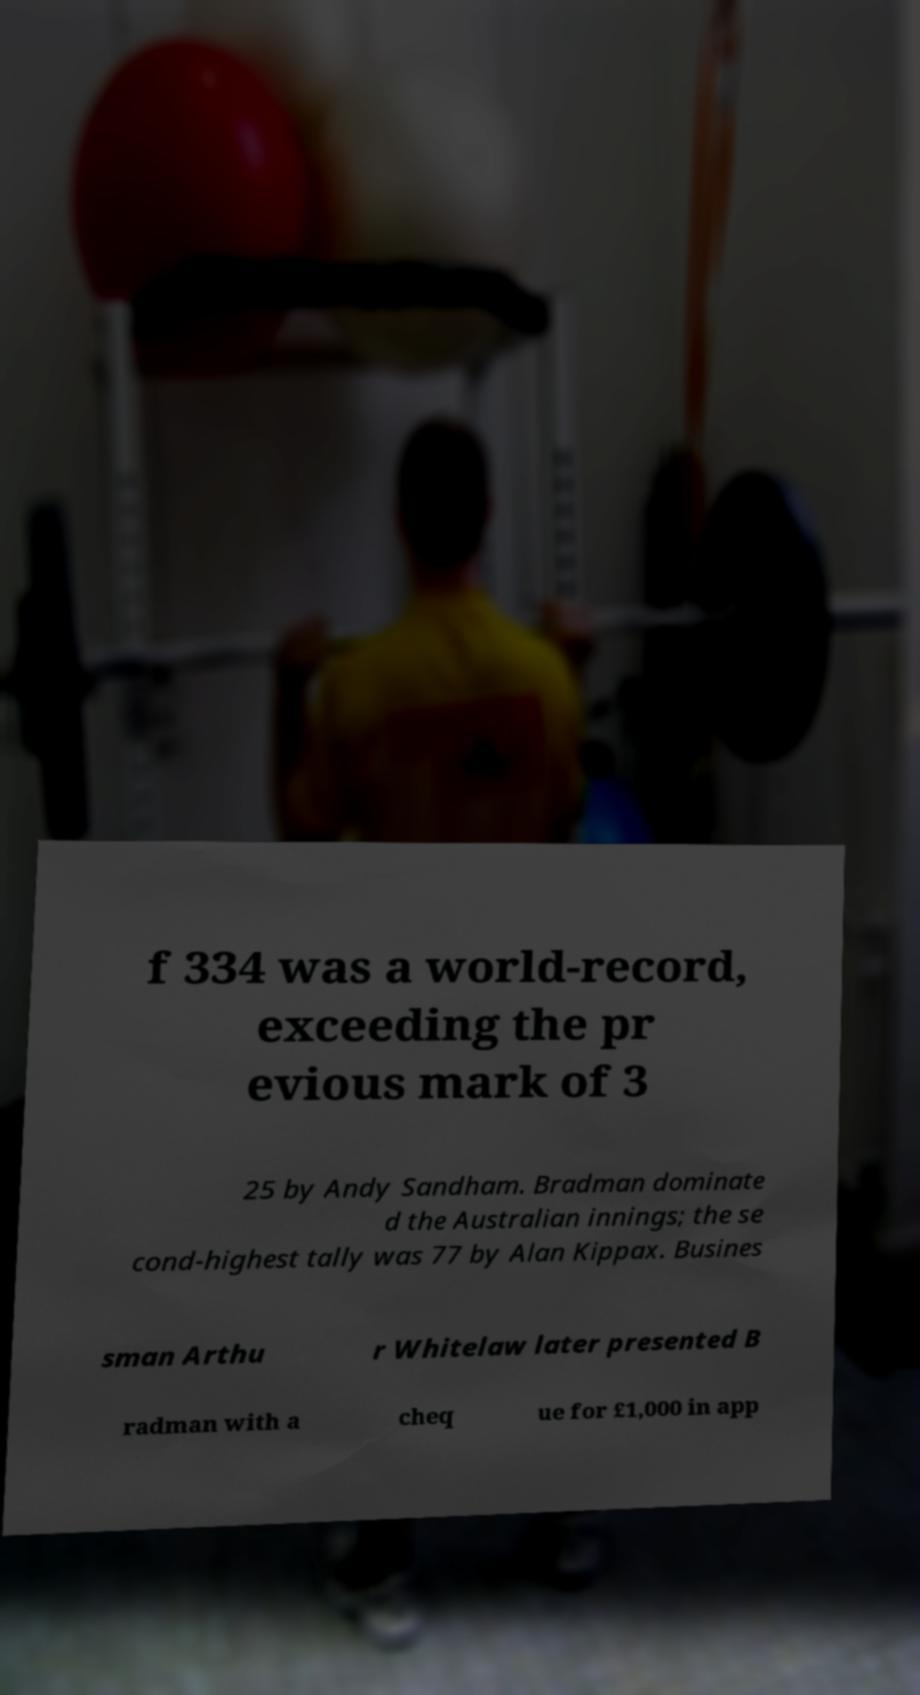There's text embedded in this image that I need extracted. Can you transcribe it verbatim? f 334 was a world-record, exceeding the pr evious mark of 3 25 by Andy Sandham. Bradman dominate d the Australian innings; the se cond-highest tally was 77 by Alan Kippax. Busines sman Arthu r Whitelaw later presented B radman with a cheq ue for £1,000 in app 